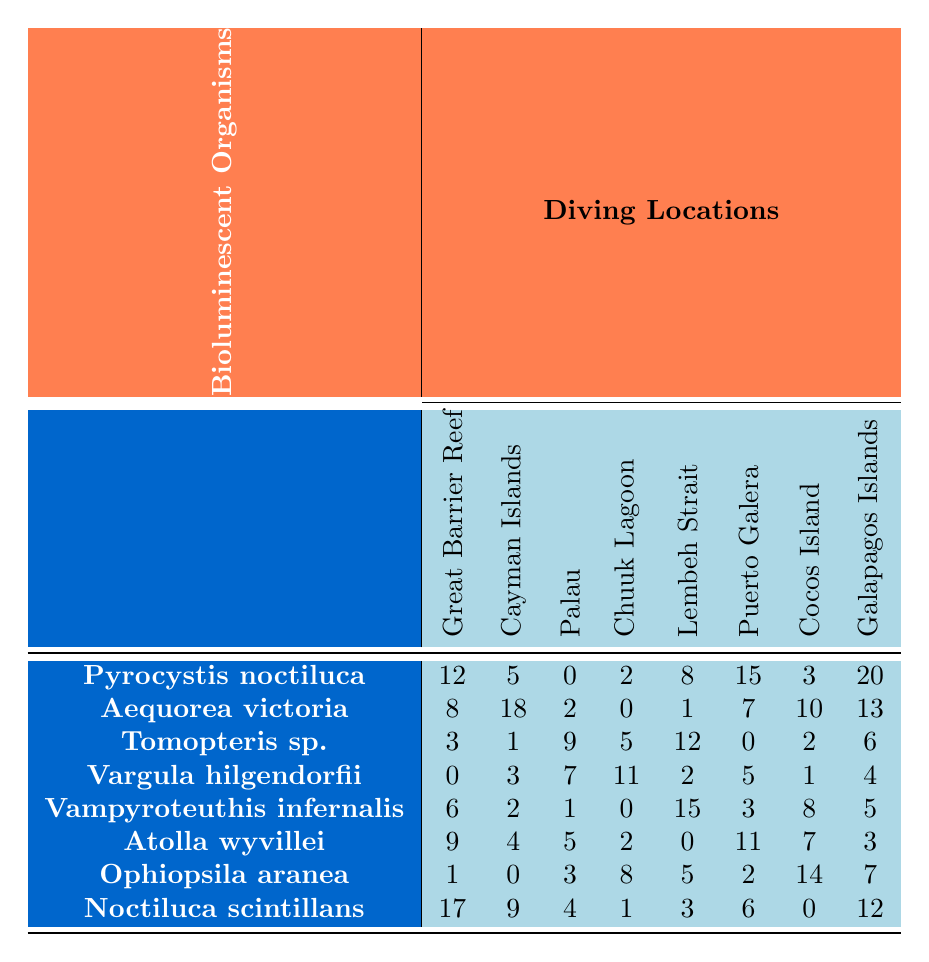What is the most frequently occurring bioluminescent organism in the Great Barrier Reef? The table shows the occurrences of various bioluminescent organisms in different diving locations. In the Great Barrier Reef, Pyrocystis noctiluca has the highest occurrence at 12.
Answer: Pyrocystis noctiluca Which diving location has the highest occurrence of Aequorea victoria? By checking the occurrences in the column for Aequorea victoria, the Cayman Islands have the highest occurrence at 18.
Answer: Cayman Islands What is the total number of occurrences for Vampyroteuthis infernalis across all diving locations? To find the total, add the occurrences: 6 (Great Barrier Reef) + 2 (Cayman Islands) + 1 (Palau) + 0 (Chuuk Lagoon) + 15 (Lembeh Strait) + 3 (Puerto Galera) + 8 (Cocos Island) + 5 (Galapagos Islands) = 40.
Answer: 40 Is there any bioluminescent organism that has the same number of occurrences in both Puerto Galera and Lembeh Strait? By comparing the values in the table for both locations, Atolla wyvillei has 11 occurrences in Puerto Galera and 0 in Lembeh Strait; none match. Therefore, there is no organism with the same occurrences.
Answer: No What is the average number of occurrences of bioluminescent organisms at Cocos Island? For Cocos Island, the occurrences are: 3, 10, 2, 1, 8, 7, 14, 0. To get the average, sum these values (3 + 10 + 2 + 1 + 8 + 7 + 14 + 0 = 45) and divide by the number of organisms (8): 45 / 8 = 5.625.
Answer: 5.625 Which diving location has the second-highest occurrence of Tomopteris sp.? The occurrences for Tomopteris sp. are as follows: 3 (Great Barrier Reef), 1 (Cayman Islands), 9 (Palau), 5 (Chuuk Lagoon), 12 (Lembeh Strait), 0 (Puerto Galera), 2 (Cocos Island), 6 (Galapagos Islands). The highest is Lembeh Strait at 12, followed by Palau with 9.
Answer: Palau How many bioluminescent organisms have more occurrences in the Great Barrier Reef than in the Galapagos Islands? Comparing the occurrences, the organisms with higher occurrences in the Great Barrier Reef than the Galapagos Islands are: Pyrocystis noctiluca (12 vs 20), Aequorea victoria (8 vs 13), Atolla wyvillei (9 vs 3), and Noctiluca scintillans (17 vs 12). This gives a total of four organisms.
Answer: 4 What is the difference in occurrences of Ophiopsila aranea between the Cayman Islands and Cocos Island? The occurrences for Ophiopsila aranea are 0 for Cayman Islands and 14 for Cocos Island. The difference is 14 - 0, which equals 14.
Answer: 14 How many locations have more than 10 occurrences of Noctiluca scintillans? Looking at the occurrences of Noctiluca scintillans: 17 (Great Barrier Reef), 9 (Cayman Islands), 4 (Palau), 1 (Chuuk Lagoon), 3 (Lembeh Strait), 6 (Puerto Galera), 0 (Cocos Island), and 12 (Galapagos Islands). Only Great Barrier Reef (17) and Galapagos Islands (12) exceed 10. Thus, there are 2 locations.
Answer: 2 